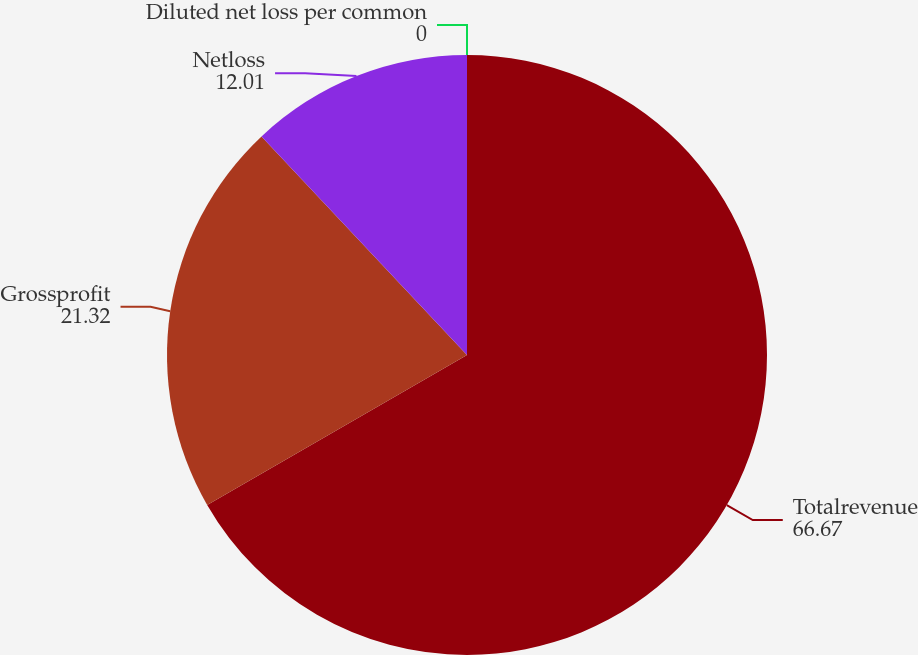<chart> <loc_0><loc_0><loc_500><loc_500><pie_chart><fcel>Totalrevenue<fcel>Grossprofit<fcel>Netloss<fcel>Diluted net loss per common<nl><fcel>66.67%<fcel>21.32%<fcel>12.01%<fcel>0.0%<nl></chart> 